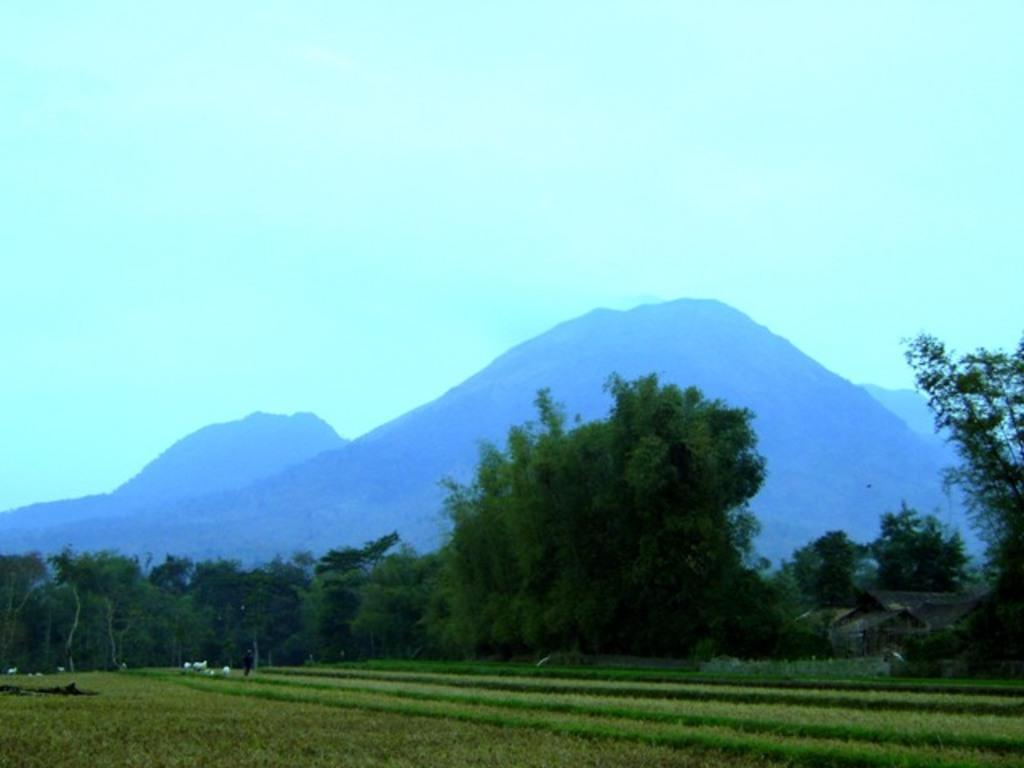How would you summarize this image in a sentence or two? In the foreground of the picture we can see crops. In the middle of the picture there are trees. In the background there are hills. At the top it is sky. 